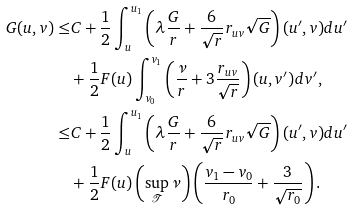Convert formula to latex. <formula><loc_0><loc_0><loc_500><loc_500>G ( u , v ) \leq & C + \frac { 1 } { 2 } \int ^ { u _ { 1 } } _ { u } \left ( \lambda \frac { G } { r } + \frac { 6 } { \sqrt { r } } r _ { u v } \sqrt { G } \right ) ( u ^ { \prime } , v ) d u ^ { \prime } \\ & + \frac { 1 } { 2 } F ( u ) \int ^ { v _ { 1 } } _ { v _ { 0 } } \left ( \frac { \nu } { r } + 3 \frac { r _ { u v } } { \sqrt { r } } \right ) ( u , v ^ { \prime } ) d v ^ { \prime } , \\ \leq & C + \frac { 1 } { 2 } \int ^ { u _ { 1 } } _ { u } \left ( \lambda \frac { G } { r } + \frac { 6 } { \sqrt { r } } r _ { u v } \sqrt { G } \right ) ( u ^ { \prime } , v ) d u ^ { \prime } \\ & + \frac { 1 } { 2 } F ( u ) \left ( \sup _ { \mathcal { T } } { \nu } \right ) \left ( \frac { v _ { 1 } - v _ { 0 } } { r _ { 0 } } + \frac { 3 } { \sqrt { r _ { 0 } } } \right ) .</formula> 